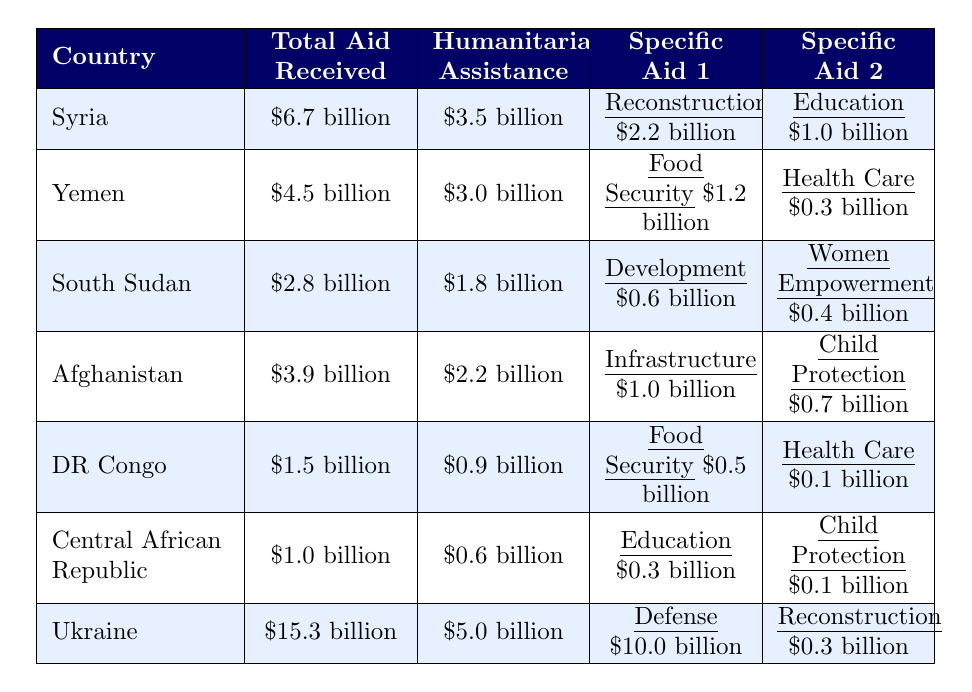What is the total aid received by Ukraine? The table shows that Ukraine has received a total of $15.3 billion in aid.
Answer: $15.3 billion Which country received the most humanitarian assistance? Looking at the "Humanitarian Assistance" column, Syria received the highest amount at $3.5 billion.
Answer: Syria What is the total aid received by South Sudan? The table indicates that South Sudan received a total of $2.8 billion in aid.
Answer: $2.8 billion How much of the aid received by Yemen was for Food Security? In the table, it indicates that Yemen received $1.2 billion specifically for Food Security.
Answer: $1.2 billion Which two countries received the least total aid? The total aid amounts for the Central African Republic ($1.0 billion) and the Democratic Republic of the Congo ($1.5 billion) are the lowest.
Answer: Central African Republic and Democratic Republic of the Congo What is the difference in total aid received between Syria and Yemen? Syria received $6.7 billion and Yemen received $4.5 billion. The difference is $6.7 billion - $4.5 billion = $2.2 billion.
Answer: $2.2 billion If we combine the total aid of South Sudan and Afghanistan, what do we get? Adding South Sudan's total of $2.8 billion and Afghanistan's total of $3.9 billion gives us $2.8 billion + $3.9 billion = $6.7 billion.
Answer: $6.7 billion Did any country receive more than $10 billion in defense aid? Yes, Ukraine received $10.0 billion in defense aid.
Answer: Yes What percentage of Ukraine's total aid was allocated to Humanitarian Assistance? Ukraine received $15.3 billion in total aid and $5.0 billion in humanitarian assistance. The percentage is ($5.0 billion / $15.3 billion) * 100 ≈ 32.68%.
Answer: Approximately 32.68% Which country received more than $5 billion in total aid but less than $7 billion? Syria falls into this category with total aid received of $6.7 billion.
Answer: Syria 